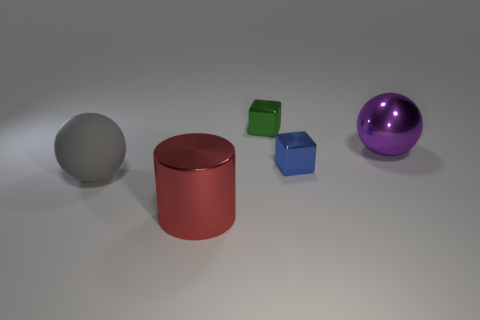Subtract 2 blocks. How many blocks are left? 0 Subtract all green things. Subtract all red things. How many objects are left? 3 Add 5 red metal cylinders. How many red metal cylinders are left? 6 Add 1 large matte spheres. How many large matte spheres exist? 2 Add 5 green cylinders. How many objects exist? 10 Subtract all purple spheres. How many spheres are left? 1 Subtract 0 cyan cylinders. How many objects are left? 5 Subtract all spheres. How many objects are left? 3 Subtract all purple spheres. Subtract all red cubes. How many spheres are left? 1 Subtract all yellow cylinders. How many purple balls are left? 1 